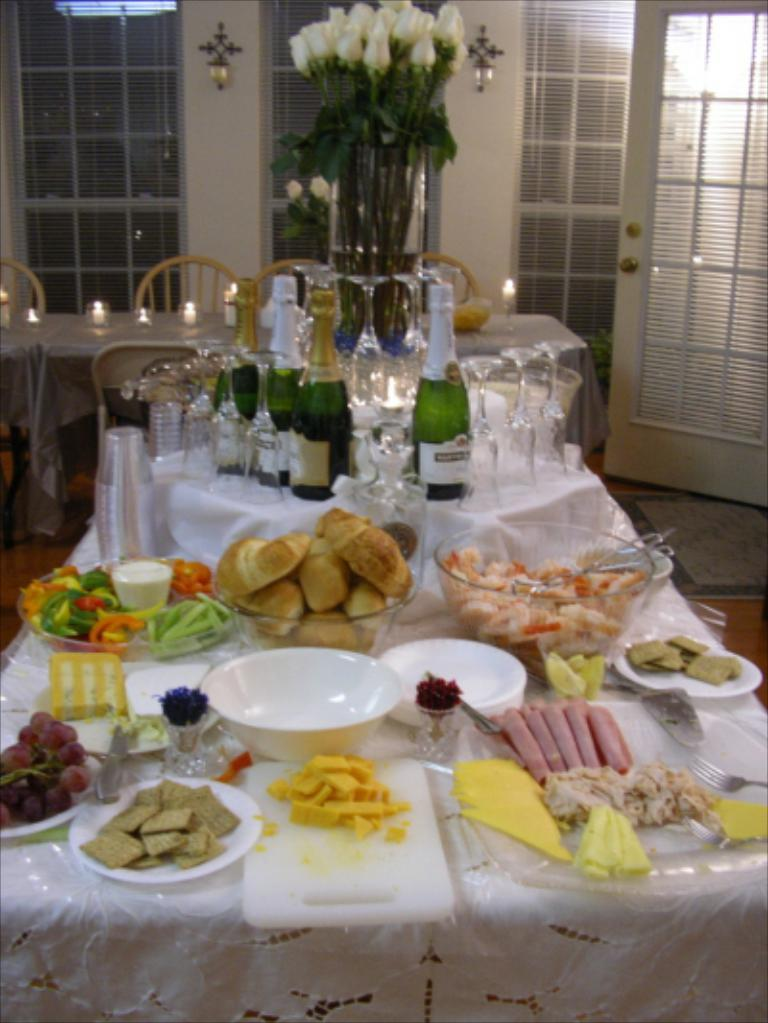What type of objects are on the table in the image? There are bottles, glasses, food bowls, and other recipes on the table in the image. What might be used for drinking in the image? The glasses on the table might be used for drinking. What might be used for serving food in the image? The food bowls on the table might be used for serving food. What is visible on the left side of the image? There is a glass window on the left side of the image. What expansion is taking place in the image? There is no expansion taking place in the image; it is a still image of objects on a table and a glass window. 